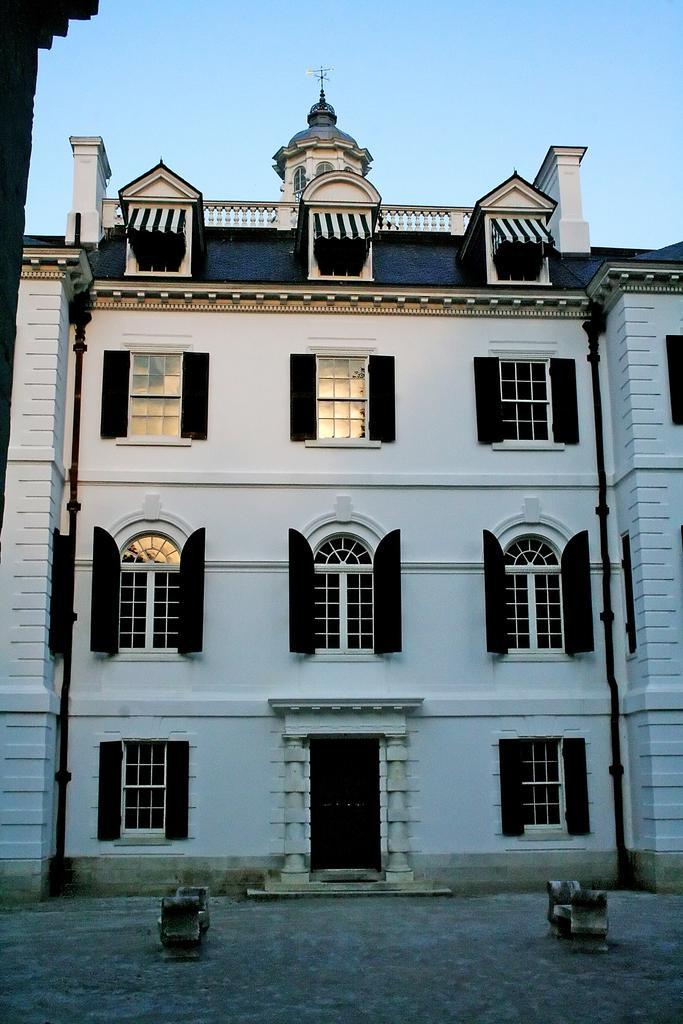Could you give a brief overview of what you see in this image? This picture is clicked outside. In the foreground we can see the benches. In the center we can see a building and we can see the windows and the door of the building. In the background we can see the sky. 